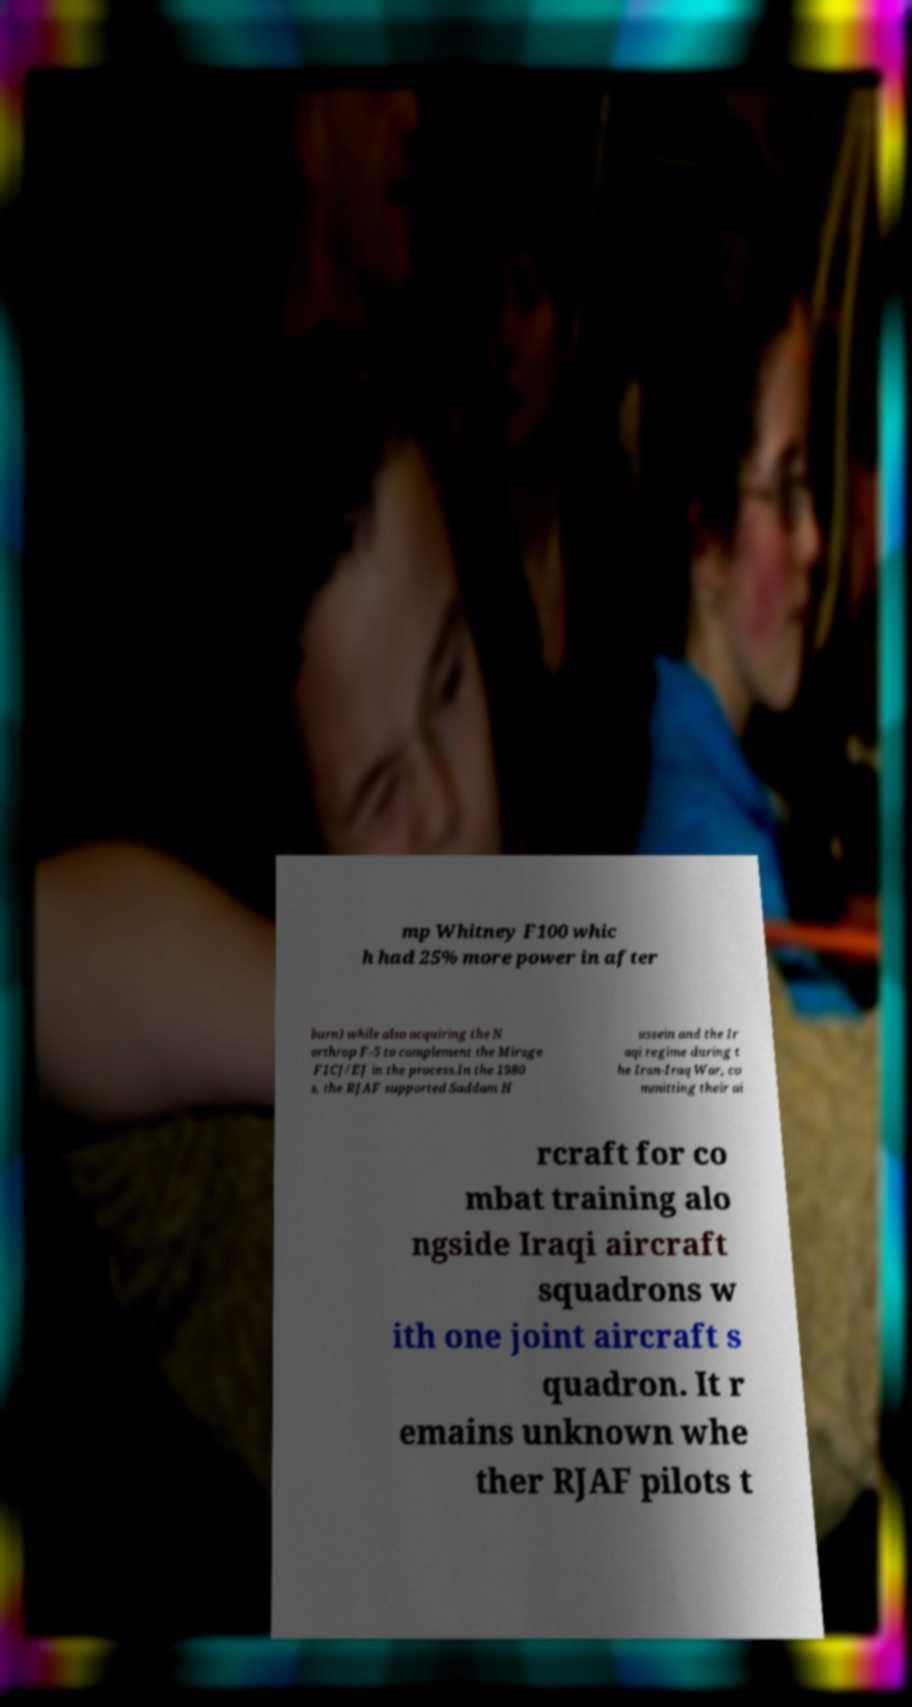Can you accurately transcribe the text from the provided image for me? mp Whitney F100 whic h had 25% more power in after burn) while also acquiring the N orthrop F-5 to complement the Mirage F1CJ/EJ in the process.In the 1980 s, the RJAF supported Saddam H ussein and the Ir aqi regime during t he Iran-Iraq War, co mmitting their ai rcraft for co mbat training alo ngside Iraqi aircraft squadrons w ith one joint aircraft s quadron. It r emains unknown whe ther RJAF pilots t 